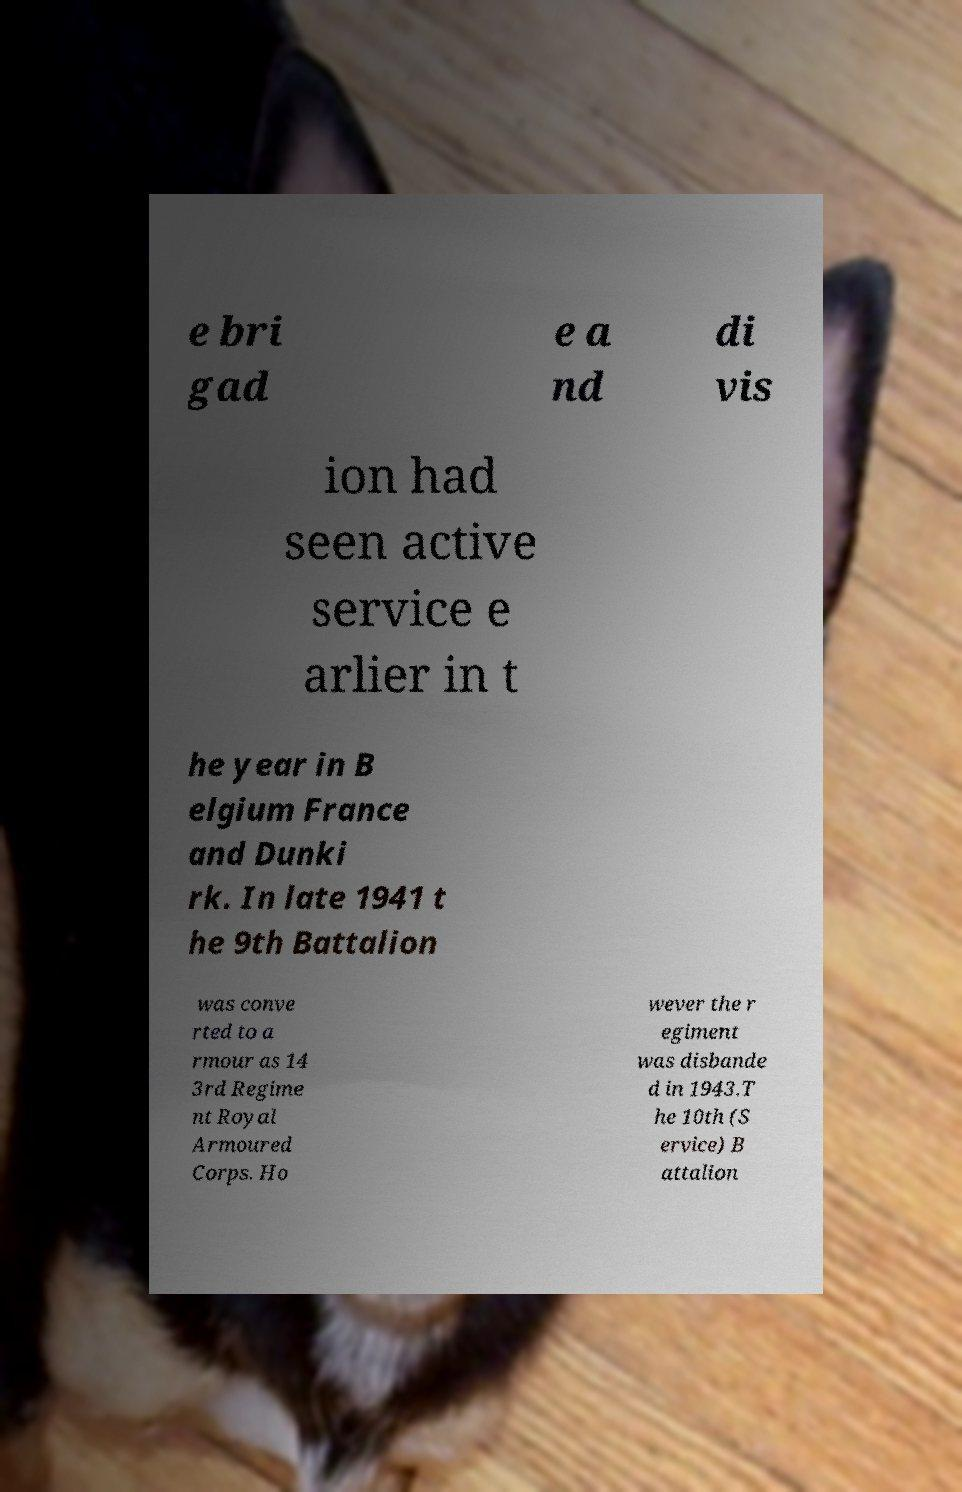There's text embedded in this image that I need extracted. Can you transcribe it verbatim? e bri gad e a nd di vis ion had seen active service e arlier in t he year in B elgium France and Dunki rk. In late 1941 t he 9th Battalion was conve rted to a rmour as 14 3rd Regime nt Royal Armoured Corps. Ho wever the r egiment was disbande d in 1943.T he 10th (S ervice) B attalion 